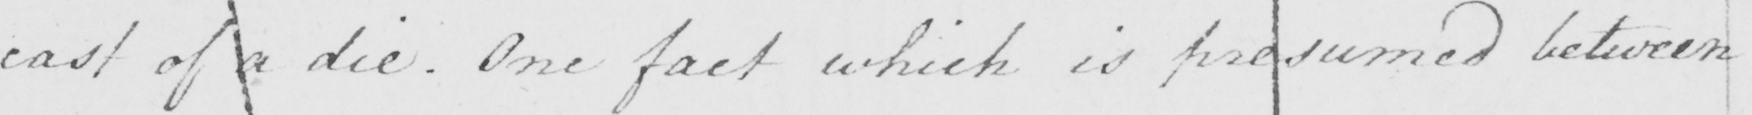Can you tell me what this handwritten text says? cast of a die . One fact which is presumed between 